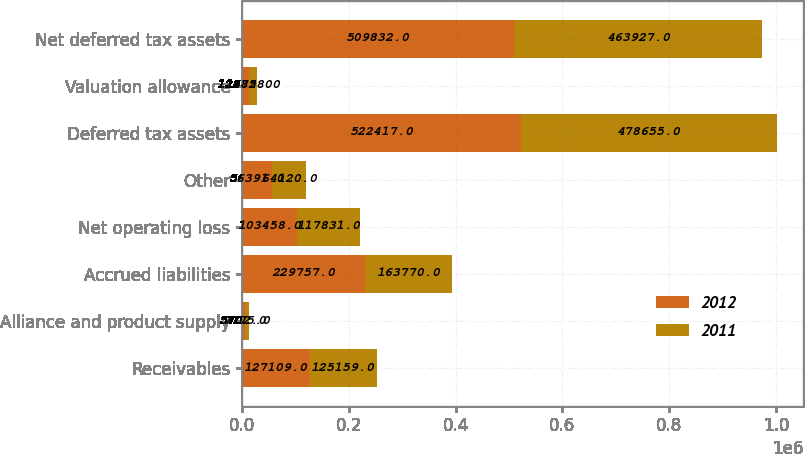Convert chart. <chart><loc_0><loc_0><loc_500><loc_500><stacked_bar_chart><ecel><fcel>Receivables<fcel>Alliance and product supply<fcel>Accrued liabilities<fcel>Net operating loss<fcel>Other<fcel>Deferred tax assets<fcel>Valuation allowance<fcel>Net deferred tax assets<nl><fcel>2012<fcel>127109<fcel>5702<fcel>229757<fcel>103458<fcel>56391<fcel>522417<fcel>12585<fcel>509832<nl><fcel>2011<fcel>125159<fcel>7775<fcel>163770<fcel>117831<fcel>64120<fcel>478655<fcel>14728<fcel>463927<nl></chart> 